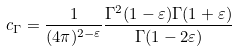Convert formula to latex. <formula><loc_0><loc_0><loc_500><loc_500>c _ { \Gamma } = \frac { 1 } { ( 4 \pi ) ^ { 2 - \varepsilon } } \frac { \Gamma ^ { 2 } ( 1 - \varepsilon ) \Gamma ( 1 + \varepsilon ) } { \Gamma ( 1 - 2 \varepsilon ) }</formula> 